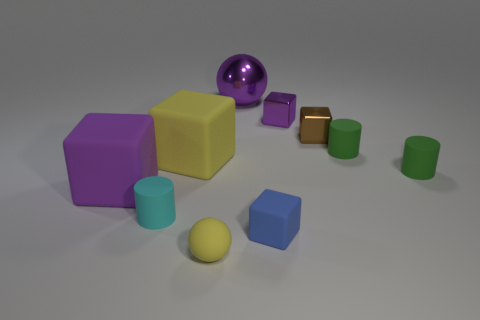Subtract all brown blocks. How many blocks are left? 4 Subtract all large yellow cubes. How many cubes are left? 4 Subtract all green blocks. Subtract all cyan balls. How many blocks are left? 5 Subtract all cylinders. How many objects are left? 7 Subtract 0 gray spheres. How many objects are left? 10 Subtract all tiny metal spheres. Subtract all tiny blue rubber blocks. How many objects are left? 9 Add 7 big matte blocks. How many big matte blocks are left? 9 Add 1 tiny yellow metal blocks. How many tiny yellow metal blocks exist? 1 